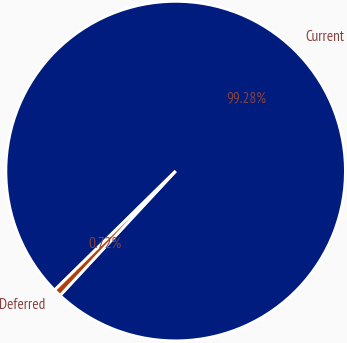Convert chart to OTSL. <chart><loc_0><loc_0><loc_500><loc_500><pie_chart><fcel>Current<fcel>Deferred<nl><fcel>99.28%<fcel>0.72%<nl></chart> 